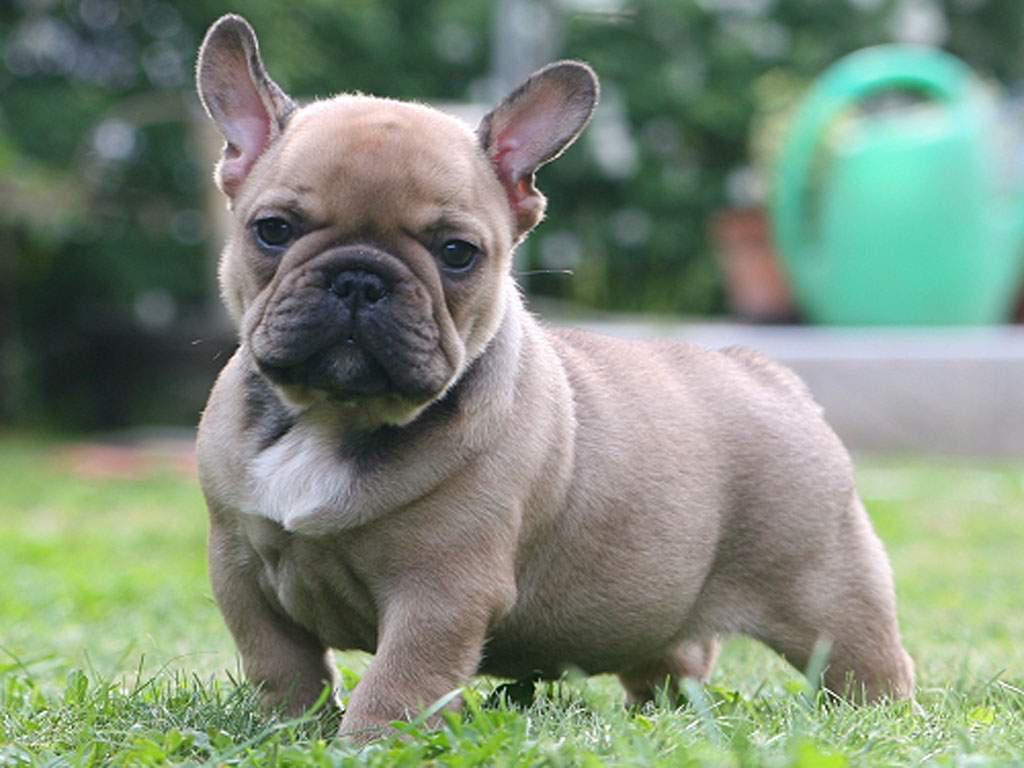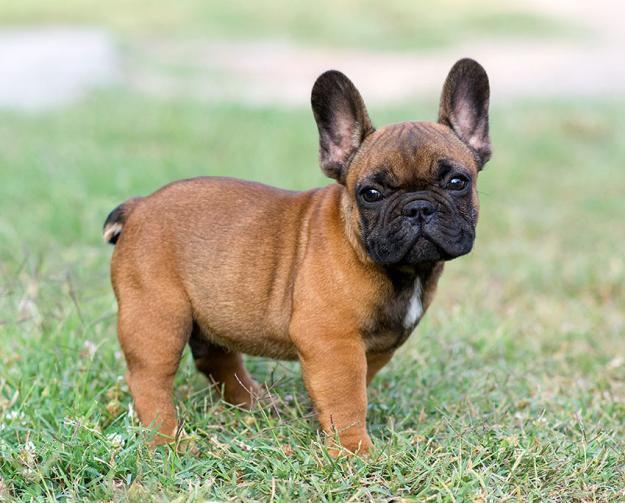The first image is the image on the left, the second image is the image on the right. For the images shown, is this caption "One of the dogs has blue eyes." true? Answer yes or no. No. The first image is the image on the left, the second image is the image on the right. For the images shown, is this caption "Both dogs are looking at the camera." true? Answer yes or no. Yes. 